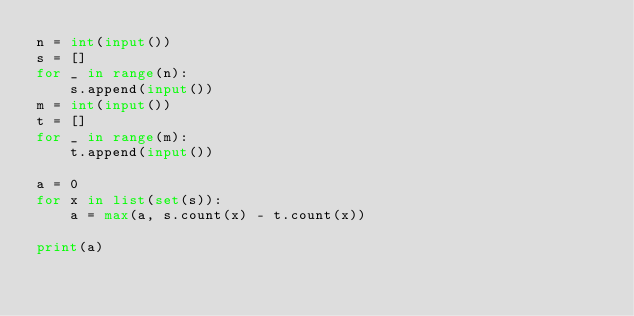<code> <loc_0><loc_0><loc_500><loc_500><_Python_>n = int(input())
s = []
for _ in range(n): 
    s.append(input())
m = int(input())
t = []
for _ in range(m): 
    t.append(input())

a = 0
for x in list(set(s)):
    a = max(a, s.count(x) - t.count(x))

print(a)</code> 